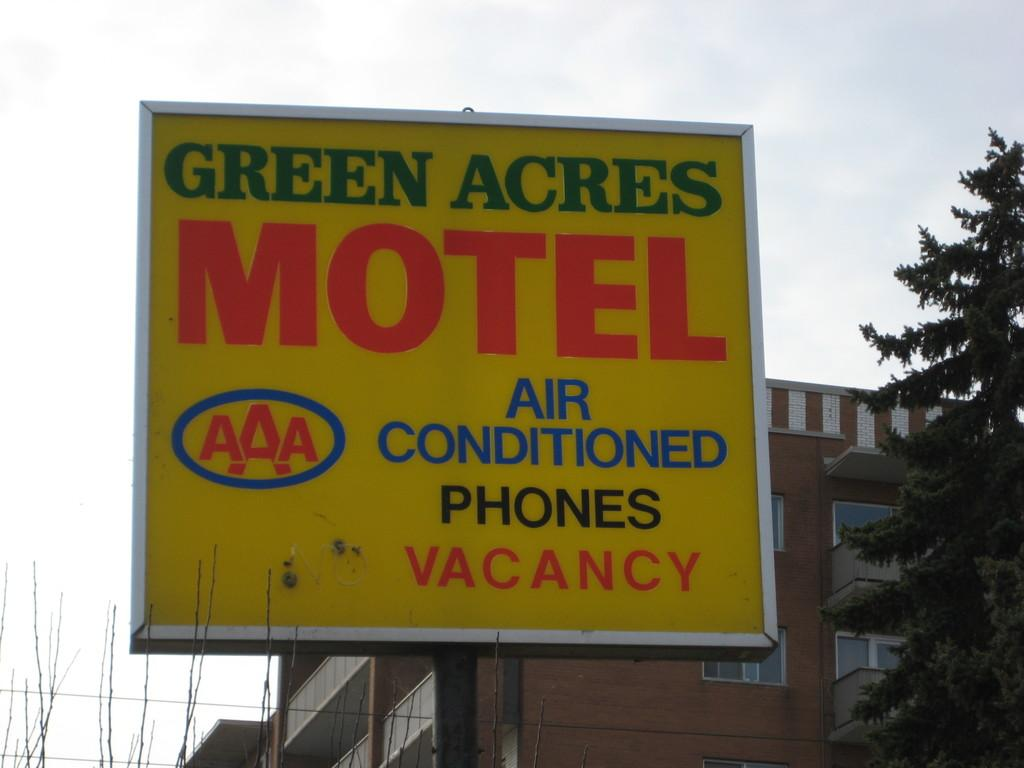<image>
Share a concise interpretation of the image provided. A sign for the Green Acres Motel informing of vacancy. 